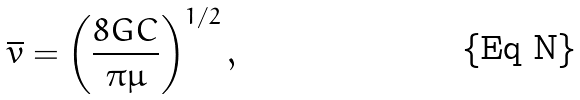<formula> <loc_0><loc_0><loc_500><loc_500>\overline { v } = \left ( \frac { 8 G C } { \pi \mu } \right ) ^ { 1 / 2 } ,</formula> 